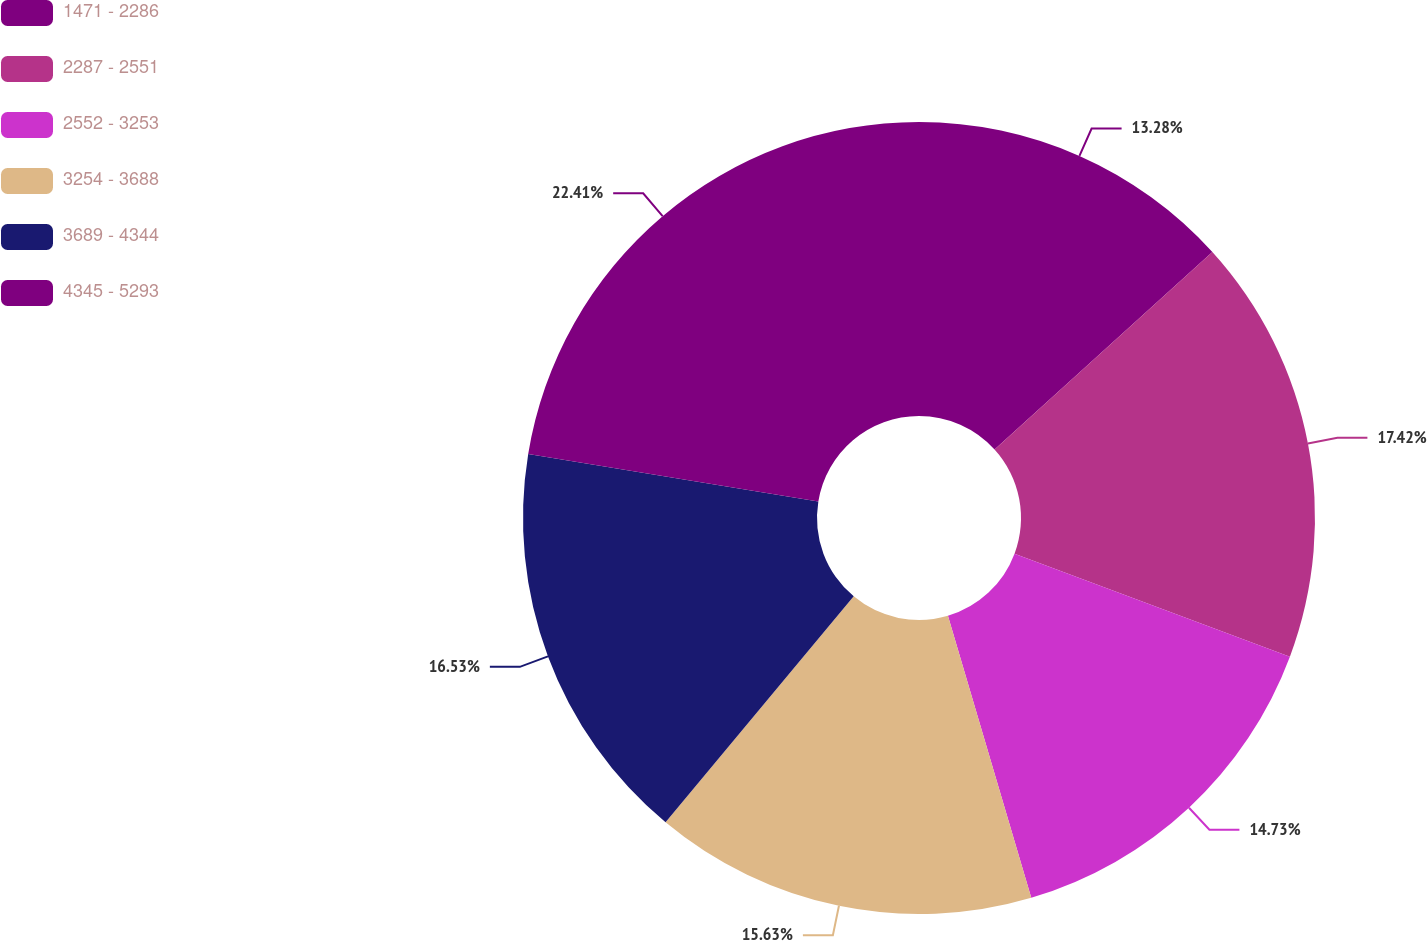<chart> <loc_0><loc_0><loc_500><loc_500><pie_chart><fcel>1471 - 2286<fcel>2287 - 2551<fcel>2552 - 3253<fcel>3254 - 3688<fcel>3689 - 4344<fcel>4345 - 5293<nl><fcel>13.28%<fcel>17.42%<fcel>14.73%<fcel>15.63%<fcel>16.53%<fcel>22.42%<nl></chart> 